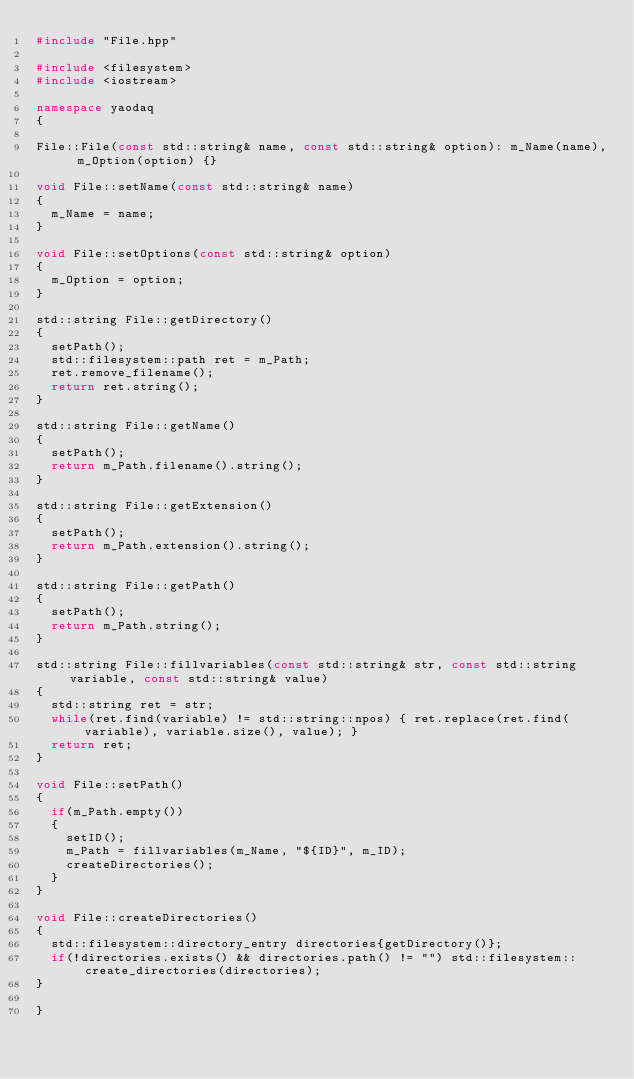<code> <loc_0><loc_0><loc_500><loc_500><_C++_>#include "File.hpp"

#include <filesystem>
#include <iostream>

namespace yaodaq
{

File::File(const std::string& name, const std::string& option): m_Name(name), m_Option(option) {}

void File::setName(const std::string& name)
{
  m_Name = name;
}

void File::setOptions(const std::string& option)
{
  m_Option = option;
}

std::string File::getDirectory()
{
  setPath();
  std::filesystem::path ret = m_Path;
  ret.remove_filename();
  return ret.string();
}

std::string File::getName()
{
  setPath();
  return m_Path.filename().string();
}

std::string File::getExtension()
{
  setPath();
  return m_Path.extension().string();
}

std::string File::getPath()
{
  setPath();
  return m_Path.string();
}

std::string File::fillvariables(const std::string& str, const std::string variable, const std::string& value)
{
  std::string ret = str;
  while(ret.find(variable) != std::string::npos) { ret.replace(ret.find(variable), variable.size(), value); }
  return ret;
}

void File::setPath()
{
  if(m_Path.empty())
  {
    setID();
    m_Path = fillvariables(m_Name, "${ID}", m_ID);
    createDirectories();
  }
}

void File::createDirectories()
{
  std::filesystem::directory_entry directories{getDirectory()};
  if(!directories.exists() && directories.path() != "") std::filesystem::create_directories(directories);
}

}
</code> 